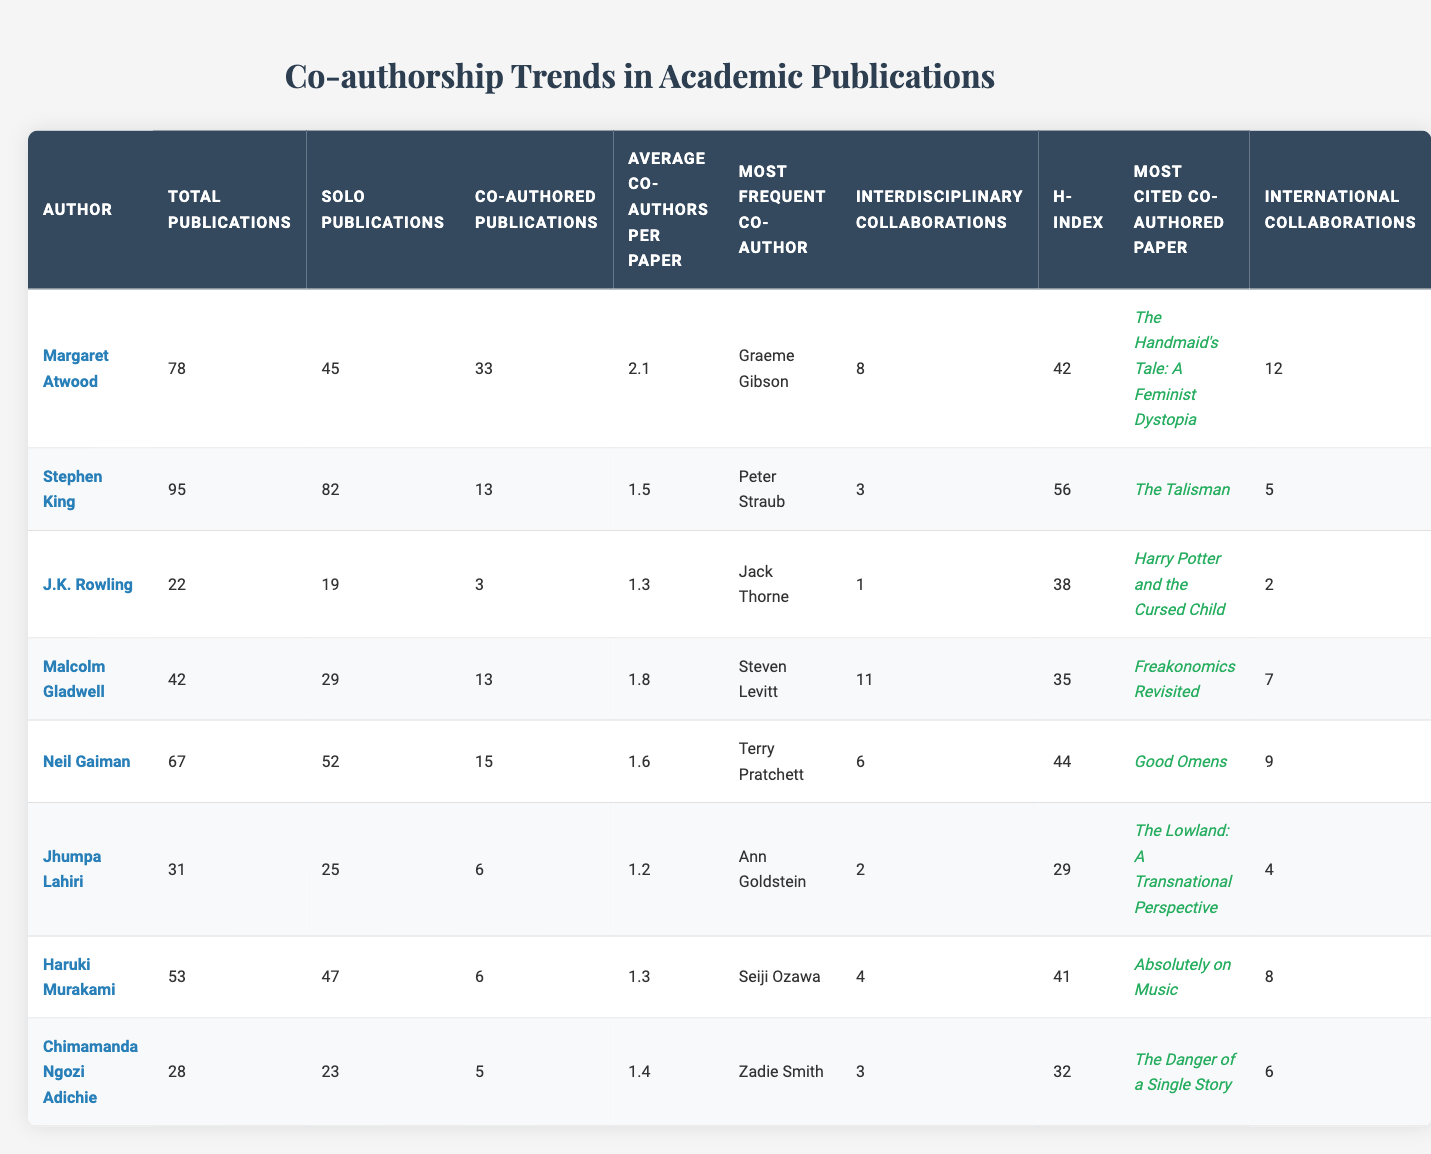What is the total number of publications by Margaret Atwood? Margaret Atwood has 78 total publications listed in the table.
Answer: 78 Who is the most frequent co-author for Stephen King? According to the table, Stephen King's most frequent co-author is Peter Straub.
Answer: Peter Straub What percentage of J.K. Rowling's publications are co-authored? J.K. Rowling has 3 co-authored publications out of 22 total publications, which is approximately 13.64% (3/22 * 100).
Answer: 13.64% Which author has the highest H-index? Upon examining the H-index values, Stephen King has the highest H-index of 56.
Answer: 56 How many publications does Neil Gaiman have compared to Haruki Murakami? Neil Gaiman has 67 total publications, while Haruki Murakami has 53, so Gaiman has 14 more publications than Murakami.
Answer: 14 What is the average number of co-authors per paper for Malcolm Gladwell? The table lists that Malcolm Gladwell has an average of 1.8 co-authors per paper.
Answer: 1.8 Is Jhumpa Lahiri's H-index greater than 30? Jhumpa Lahiri's H-index is 29, which is not greater than 30.
Answer: No Which author has the second highest number of interdisciplinary collaborations? By looking at the values, Malcolm Gladwell has 11 interdisciplinary collaborations, making him the second highest after Margaret Atwood (8).
Answer: Malcolm Gladwell What is the average number of co-authors per paper for all authors combined? The average can be found by summing the average co-authors per paper for all authors (2.1 + 1.5 + 1.3 + 1.8 + 1.6 + 1.2 + 1.3 + 1.4)/8 = 1.575.
Answer: 1.575 Which author has the most international collaborations? Upon reviewing the table, Margaret Atwood has the most international collaborations with a total of 12.
Answer: 12 